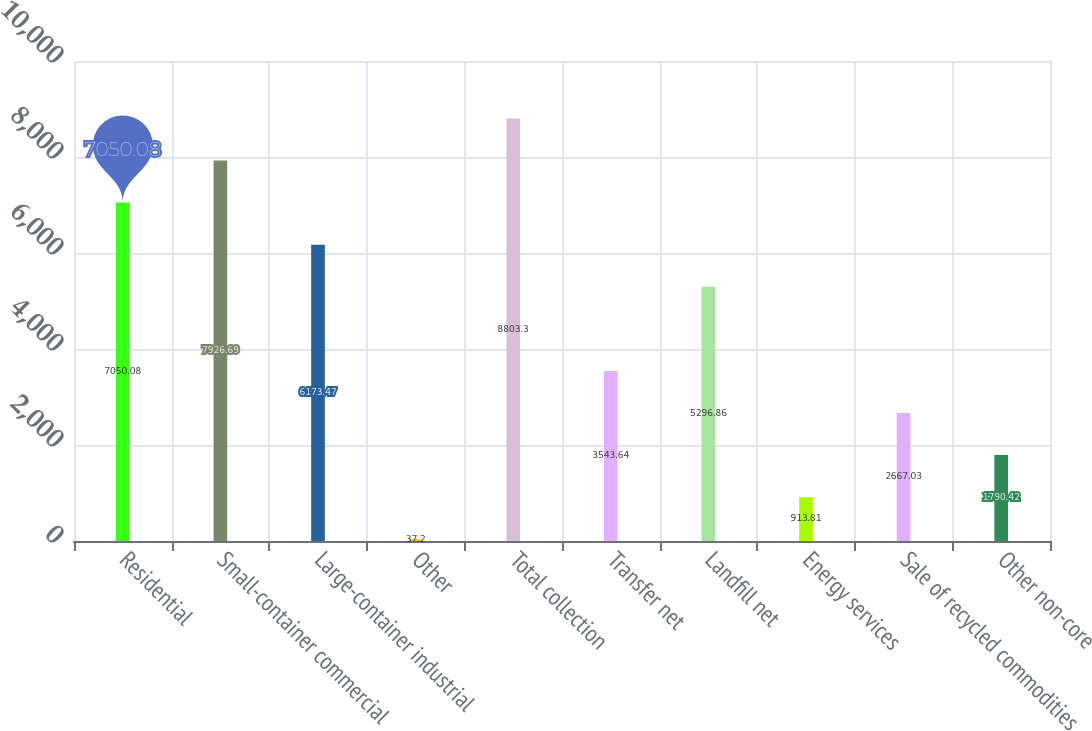Convert chart to OTSL. <chart><loc_0><loc_0><loc_500><loc_500><bar_chart><fcel>Residential<fcel>Small-container commercial<fcel>Large-container industrial<fcel>Other<fcel>Total collection<fcel>Transfer net<fcel>Landfill net<fcel>Energy services<fcel>Sale of recycled commodities<fcel>Other non-core<nl><fcel>7050.08<fcel>7926.69<fcel>6173.47<fcel>37.2<fcel>8803.3<fcel>3543.64<fcel>5296.86<fcel>913.81<fcel>2667.03<fcel>1790.42<nl></chart> 